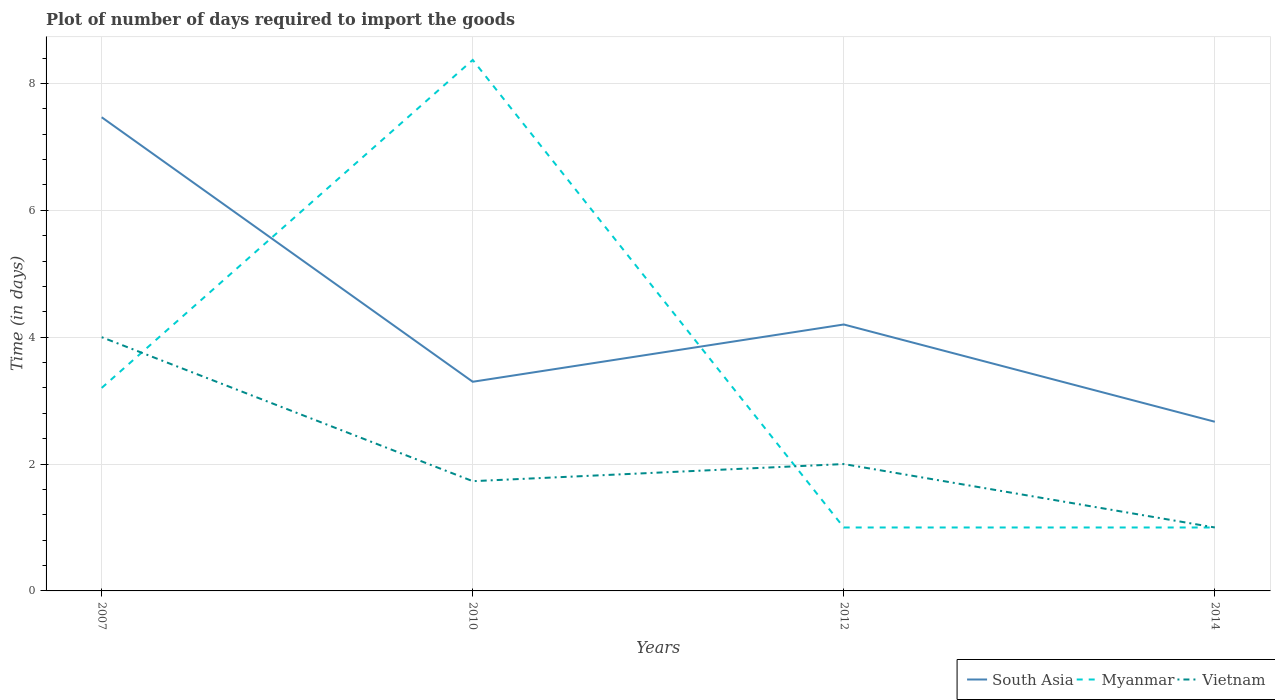Across all years, what is the maximum time required to import goods in South Asia?
Offer a very short reply. 2.67. What is the total time required to import goods in South Asia in the graph?
Give a very brief answer. 4.17. What is the difference between the highest and the second highest time required to import goods in Myanmar?
Offer a very short reply. 7.37. Are the values on the major ticks of Y-axis written in scientific E-notation?
Make the answer very short. No. What is the title of the graph?
Offer a very short reply. Plot of number of days required to import the goods. Does "Senegal" appear as one of the legend labels in the graph?
Your answer should be compact. No. What is the label or title of the X-axis?
Keep it short and to the point. Years. What is the label or title of the Y-axis?
Your answer should be very brief. Time (in days). What is the Time (in days) in South Asia in 2007?
Provide a short and direct response. 7.47. What is the Time (in days) in Myanmar in 2007?
Make the answer very short. 3.2. What is the Time (in days) in Vietnam in 2007?
Offer a terse response. 4. What is the Time (in days) in South Asia in 2010?
Give a very brief answer. 3.3. What is the Time (in days) in Myanmar in 2010?
Provide a succinct answer. 8.37. What is the Time (in days) of Vietnam in 2010?
Ensure brevity in your answer.  1.73. What is the Time (in days) of South Asia in 2012?
Offer a very short reply. 4.2. What is the Time (in days) of Myanmar in 2012?
Make the answer very short. 1. What is the Time (in days) of Vietnam in 2012?
Make the answer very short. 2. What is the Time (in days) in South Asia in 2014?
Keep it short and to the point. 2.67. What is the Time (in days) of Myanmar in 2014?
Give a very brief answer. 1. What is the Time (in days) of Vietnam in 2014?
Provide a succinct answer. 1. Across all years, what is the maximum Time (in days) of South Asia?
Offer a very short reply. 7.47. Across all years, what is the maximum Time (in days) of Myanmar?
Give a very brief answer. 8.37. Across all years, what is the minimum Time (in days) in South Asia?
Ensure brevity in your answer.  2.67. Across all years, what is the minimum Time (in days) in Vietnam?
Offer a very short reply. 1. What is the total Time (in days) in South Asia in the graph?
Ensure brevity in your answer.  17.63. What is the total Time (in days) in Myanmar in the graph?
Give a very brief answer. 13.57. What is the total Time (in days) in Vietnam in the graph?
Offer a very short reply. 8.73. What is the difference between the Time (in days) in South Asia in 2007 and that in 2010?
Your answer should be very brief. 4.17. What is the difference between the Time (in days) of Myanmar in 2007 and that in 2010?
Your answer should be compact. -5.17. What is the difference between the Time (in days) of Vietnam in 2007 and that in 2010?
Provide a succinct answer. 2.27. What is the difference between the Time (in days) of South Asia in 2007 and that in 2012?
Ensure brevity in your answer.  3.27. What is the difference between the Time (in days) of Myanmar in 2007 and that in 2012?
Your answer should be very brief. 2.2. What is the difference between the Time (in days) in Vietnam in 2007 and that in 2012?
Provide a succinct answer. 2. What is the difference between the Time (in days) in South Asia in 2007 and that in 2014?
Provide a succinct answer. 4.8. What is the difference between the Time (in days) of Myanmar in 2007 and that in 2014?
Make the answer very short. 2.2. What is the difference between the Time (in days) in Vietnam in 2007 and that in 2014?
Your response must be concise. 3. What is the difference between the Time (in days) of South Asia in 2010 and that in 2012?
Provide a short and direct response. -0.9. What is the difference between the Time (in days) in Myanmar in 2010 and that in 2012?
Give a very brief answer. 7.37. What is the difference between the Time (in days) in Vietnam in 2010 and that in 2012?
Provide a succinct answer. -0.27. What is the difference between the Time (in days) of South Asia in 2010 and that in 2014?
Your answer should be very brief. 0.63. What is the difference between the Time (in days) in Myanmar in 2010 and that in 2014?
Your answer should be compact. 7.37. What is the difference between the Time (in days) in Vietnam in 2010 and that in 2014?
Offer a terse response. 0.73. What is the difference between the Time (in days) in South Asia in 2012 and that in 2014?
Provide a succinct answer. 1.53. What is the difference between the Time (in days) of Myanmar in 2012 and that in 2014?
Your answer should be compact. 0. What is the difference between the Time (in days) in South Asia in 2007 and the Time (in days) in Myanmar in 2010?
Give a very brief answer. -0.9. What is the difference between the Time (in days) of South Asia in 2007 and the Time (in days) of Vietnam in 2010?
Your answer should be very brief. 5.74. What is the difference between the Time (in days) in Myanmar in 2007 and the Time (in days) in Vietnam in 2010?
Your answer should be very brief. 1.47. What is the difference between the Time (in days) in South Asia in 2007 and the Time (in days) in Myanmar in 2012?
Ensure brevity in your answer.  6.47. What is the difference between the Time (in days) in South Asia in 2007 and the Time (in days) in Vietnam in 2012?
Provide a succinct answer. 5.47. What is the difference between the Time (in days) of Myanmar in 2007 and the Time (in days) of Vietnam in 2012?
Your response must be concise. 1.2. What is the difference between the Time (in days) in South Asia in 2007 and the Time (in days) in Myanmar in 2014?
Provide a succinct answer. 6.47. What is the difference between the Time (in days) of South Asia in 2007 and the Time (in days) of Vietnam in 2014?
Your answer should be compact. 6.47. What is the difference between the Time (in days) of South Asia in 2010 and the Time (in days) of Myanmar in 2012?
Ensure brevity in your answer.  2.3. What is the difference between the Time (in days) of South Asia in 2010 and the Time (in days) of Vietnam in 2012?
Offer a very short reply. 1.3. What is the difference between the Time (in days) in Myanmar in 2010 and the Time (in days) in Vietnam in 2012?
Your response must be concise. 6.37. What is the difference between the Time (in days) of South Asia in 2010 and the Time (in days) of Myanmar in 2014?
Offer a terse response. 2.3. What is the difference between the Time (in days) in South Asia in 2010 and the Time (in days) in Vietnam in 2014?
Provide a short and direct response. 2.3. What is the difference between the Time (in days) of Myanmar in 2010 and the Time (in days) of Vietnam in 2014?
Provide a succinct answer. 7.37. What is the average Time (in days) of South Asia per year?
Provide a succinct answer. 4.41. What is the average Time (in days) in Myanmar per year?
Make the answer very short. 3.39. What is the average Time (in days) in Vietnam per year?
Give a very brief answer. 2.18. In the year 2007, what is the difference between the Time (in days) in South Asia and Time (in days) in Myanmar?
Keep it short and to the point. 4.27. In the year 2007, what is the difference between the Time (in days) of South Asia and Time (in days) of Vietnam?
Make the answer very short. 3.47. In the year 2010, what is the difference between the Time (in days) of South Asia and Time (in days) of Myanmar?
Ensure brevity in your answer.  -5.07. In the year 2010, what is the difference between the Time (in days) of South Asia and Time (in days) of Vietnam?
Give a very brief answer. 1.57. In the year 2010, what is the difference between the Time (in days) in Myanmar and Time (in days) in Vietnam?
Your response must be concise. 6.64. In the year 2012, what is the difference between the Time (in days) in South Asia and Time (in days) in Myanmar?
Provide a short and direct response. 3.2. In the year 2014, what is the difference between the Time (in days) in South Asia and Time (in days) in Myanmar?
Ensure brevity in your answer.  1.67. In the year 2014, what is the difference between the Time (in days) in South Asia and Time (in days) in Vietnam?
Offer a very short reply. 1.67. What is the ratio of the Time (in days) of South Asia in 2007 to that in 2010?
Provide a short and direct response. 2.26. What is the ratio of the Time (in days) of Myanmar in 2007 to that in 2010?
Your response must be concise. 0.38. What is the ratio of the Time (in days) of Vietnam in 2007 to that in 2010?
Offer a terse response. 2.31. What is the ratio of the Time (in days) in South Asia in 2007 to that in 2012?
Offer a very short reply. 1.78. What is the ratio of the Time (in days) of Myanmar in 2007 to that in 2012?
Keep it short and to the point. 3.2. What is the ratio of the Time (in days) in Vietnam in 2007 to that in 2012?
Offer a terse response. 2. What is the ratio of the Time (in days) of South Asia in 2010 to that in 2012?
Ensure brevity in your answer.  0.79. What is the ratio of the Time (in days) of Myanmar in 2010 to that in 2012?
Make the answer very short. 8.37. What is the ratio of the Time (in days) in Vietnam in 2010 to that in 2012?
Give a very brief answer. 0.86. What is the ratio of the Time (in days) in South Asia in 2010 to that in 2014?
Offer a very short reply. 1.24. What is the ratio of the Time (in days) of Myanmar in 2010 to that in 2014?
Your answer should be compact. 8.37. What is the ratio of the Time (in days) of Vietnam in 2010 to that in 2014?
Your answer should be very brief. 1.73. What is the ratio of the Time (in days) in South Asia in 2012 to that in 2014?
Your answer should be compact. 1.57. What is the difference between the highest and the second highest Time (in days) of South Asia?
Ensure brevity in your answer.  3.27. What is the difference between the highest and the second highest Time (in days) of Myanmar?
Keep it short and to the point. 5.17. What is the difference between the highest and the lowest Time (in days) of Myanmar?
Provide a succinct answer. 7.37. 